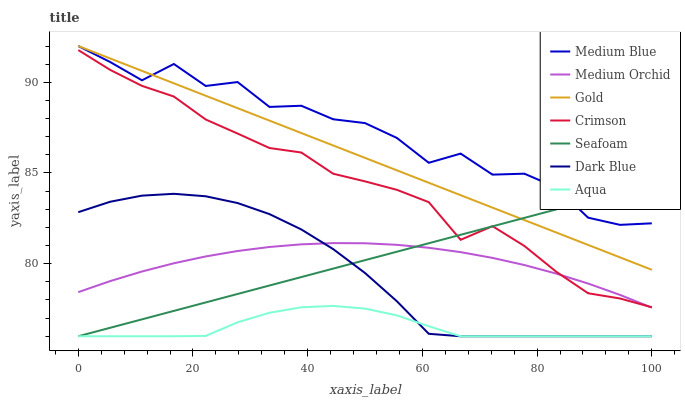Does Medium Orchid have the minimum area under the curve?
Answer yes or no. No. Does Medium Orchid have the maximum area under the curve?
Answer yes or no. No. Is Aqua the smoothest?
Answer yes or no. No. Is Aqua the roughest?
Answer yes or no. No. Does Medium Orchid have the lowest value?
Answer yes or no. No. Does Medium Orchid have the highest value?
Answer yes or no. No. Is Aqua less than Crimson?
Answer yes or no. Yes. Is Medium Blue greater than Medium Orchid?
Answer yes or no. Yes. Does Aqua intersect Crimson?
Answer yes or no. No. 